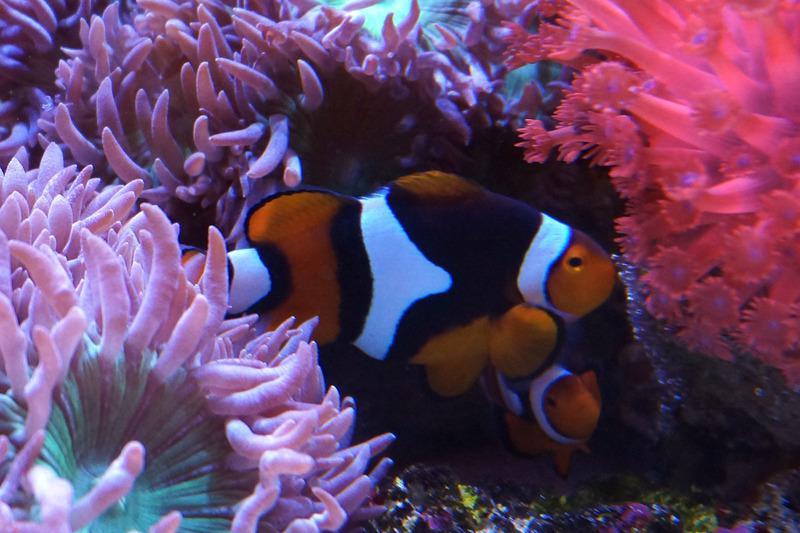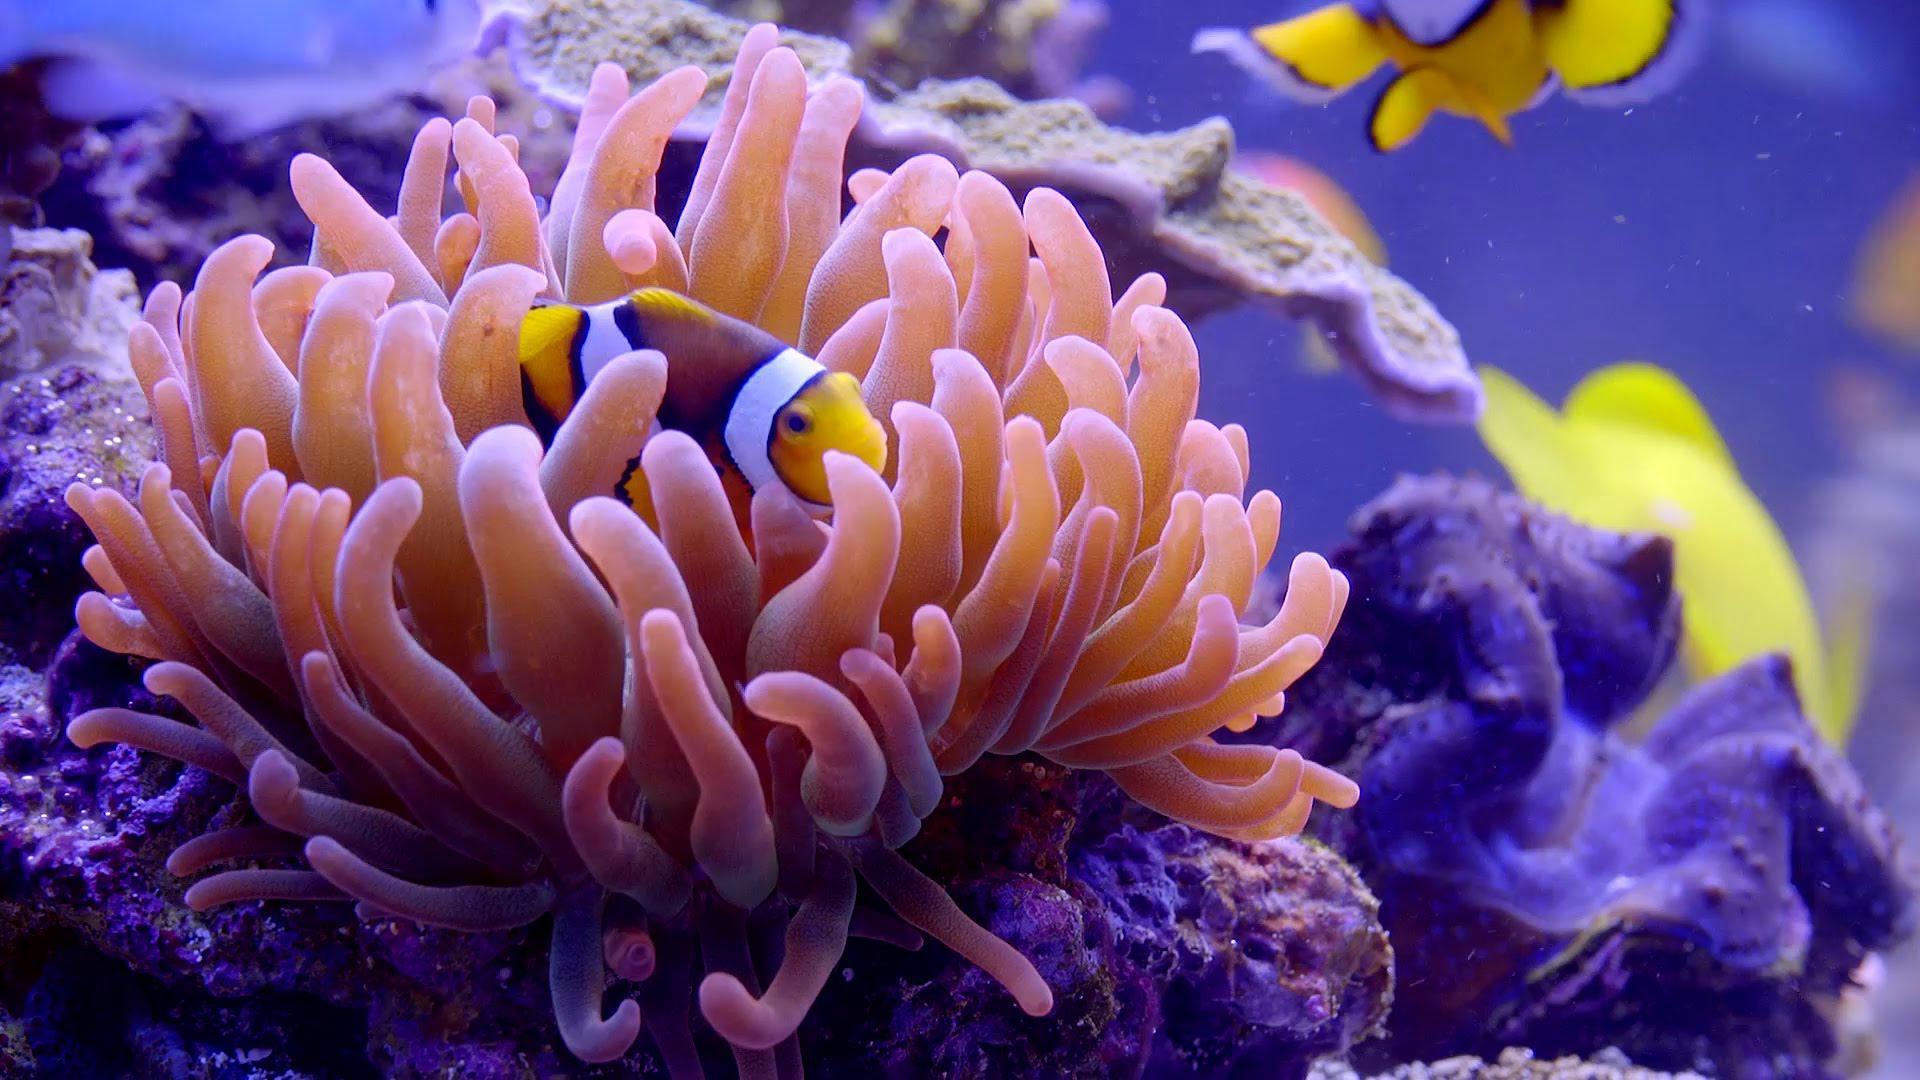The first image is the image on the left, the second image is the image on the right. Analyze the images presented: Is the assertion "A fish is swimming in the sea plant in both the images." valid? Answer yes or no. Yes. The first image is the image on the left, the second image is the image on the right. Considering the images on both sides, is "Each image shows at least one clown fish swimming among anemone." valid? Answer yes or no. Yes. 